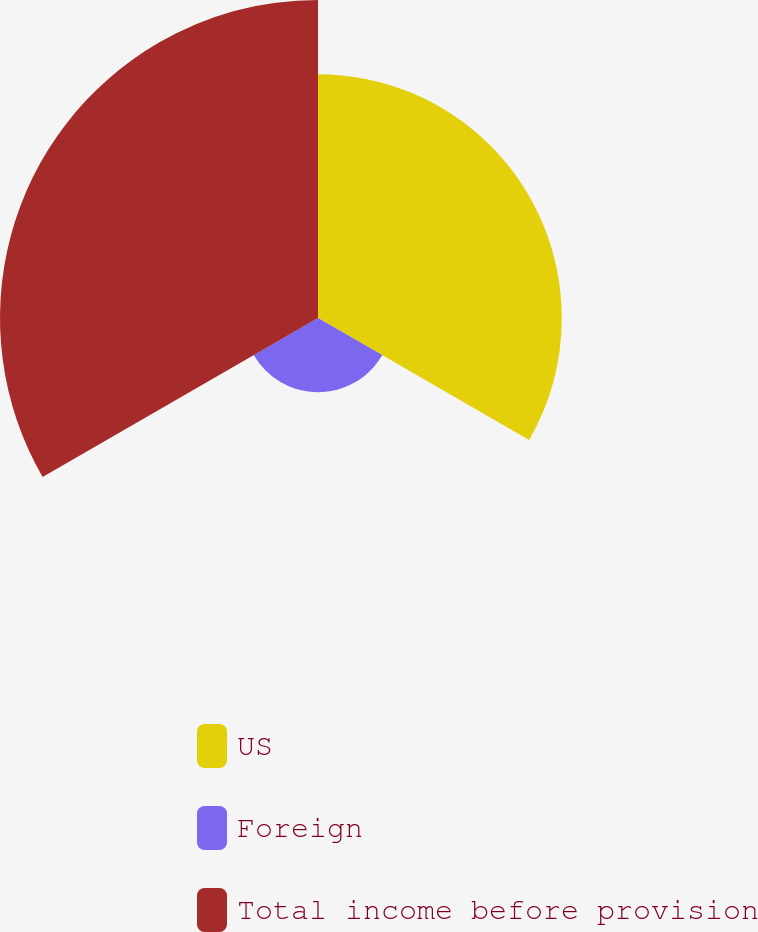<chart> <loc_0><loc_0><loc_500><loc_500><pie_chart><fcel>US<fcel>Foreign<fcel>Total income before provision<nl><fcel>38.33%<fcel>11.67%<fcel>50.0%<nl></chart> 